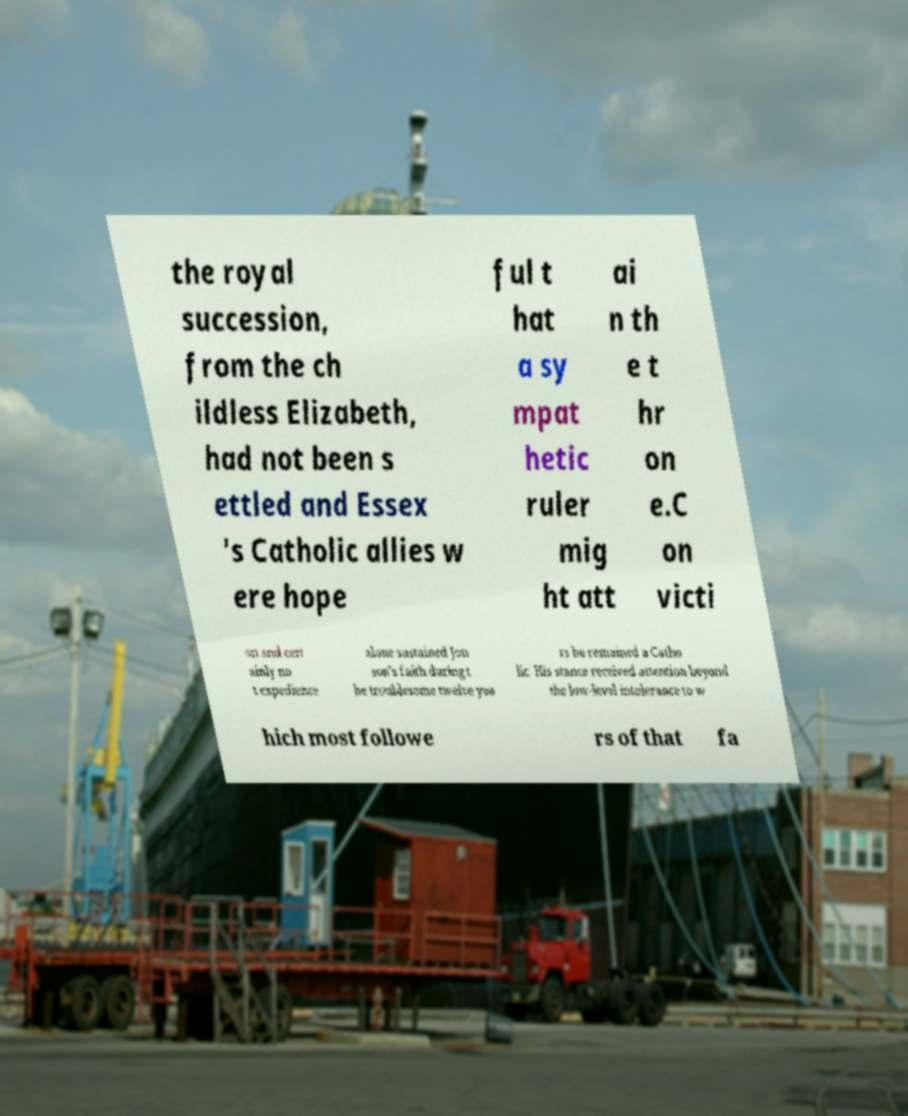Please identify and transcribe the text found in this image. the royal succession, from the ch ildless Elizabeth, had not been s ettled and Essex 's Catholic allies w ere hope ful t hat a sy mpat hetic ruler mig ht att ai n th e t hr on e.C on victi on and cert ainly no t expedience alone sustained Jon son's faith during t he troublesome twelve yea rs he remained a Catho lic. His stance received attention beyond the low-level intolerance to w hich most followe rs of that fa 